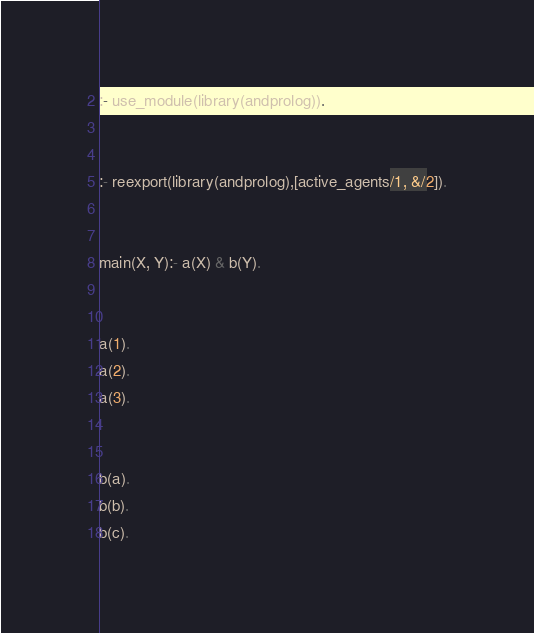Convert code to text. <code><loc_0><loc_0><loc_500><loc_500><_Perl_>

:- use_module(library(andprolog)).


:- reexport(library(andprolog),[active_agents/1, &/2]).


main(X, Y):- a(X) & b(Y).


a(1).
a(2).
a(3).


b(a).
b(b).
b(c).
</code> 